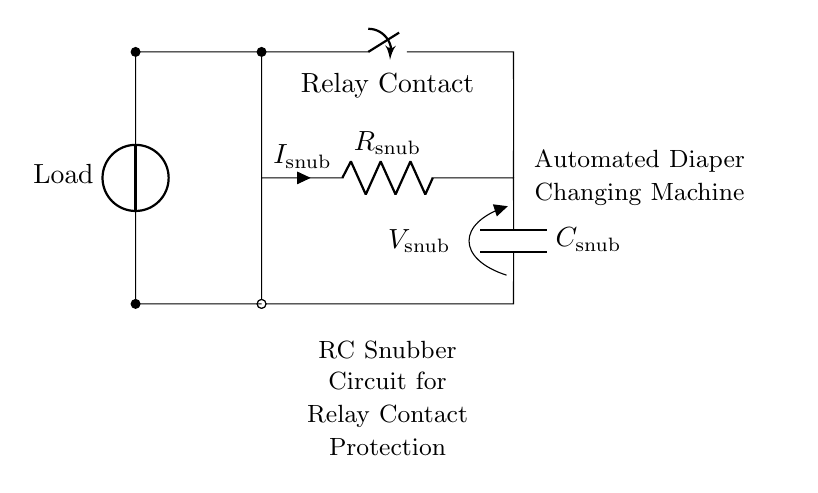What type of circuit is this? This is an RC snubber circuit, which consists of a resistor and capacitor designed to protect relay contacts. The components are arranged to block voltage spikes.
Answer: RC snubber circuit What is the component in series with the capacitor? The resistor is directly in series with the capacitor in the snubber circuit, as they are connected end-to-end.
Answer: Resistor What is the voltage across the capacitor labeled as? The voltage across the capacitor is labeled as V_snub. This indicates the potential difference across the capacitor when the circuit is operational.
Answer: V_snub What keeps the relay contact open in this circuit? The closing switch ensures that the relay contacts are operated, and its position determines if the contacts are open or closed. This particular position allows for current to flow.
Answer: Closing switch How do the resistor and capacitor primarily protect the relay contacts? The resistor and capacitor act together to absorb voltage spikes generated during switching, thereby preventing arcing at the relay contacts. This extends the life of the relay contacts by minimizing wear due to electrical stress.
Answer: Absorb voltage spikes What role does the load play in this circuit? The load represents the device or component that the relay is controlling. Its presence is essential for the circuit to function and for the relay to operate properly.
Answer: Device operation 